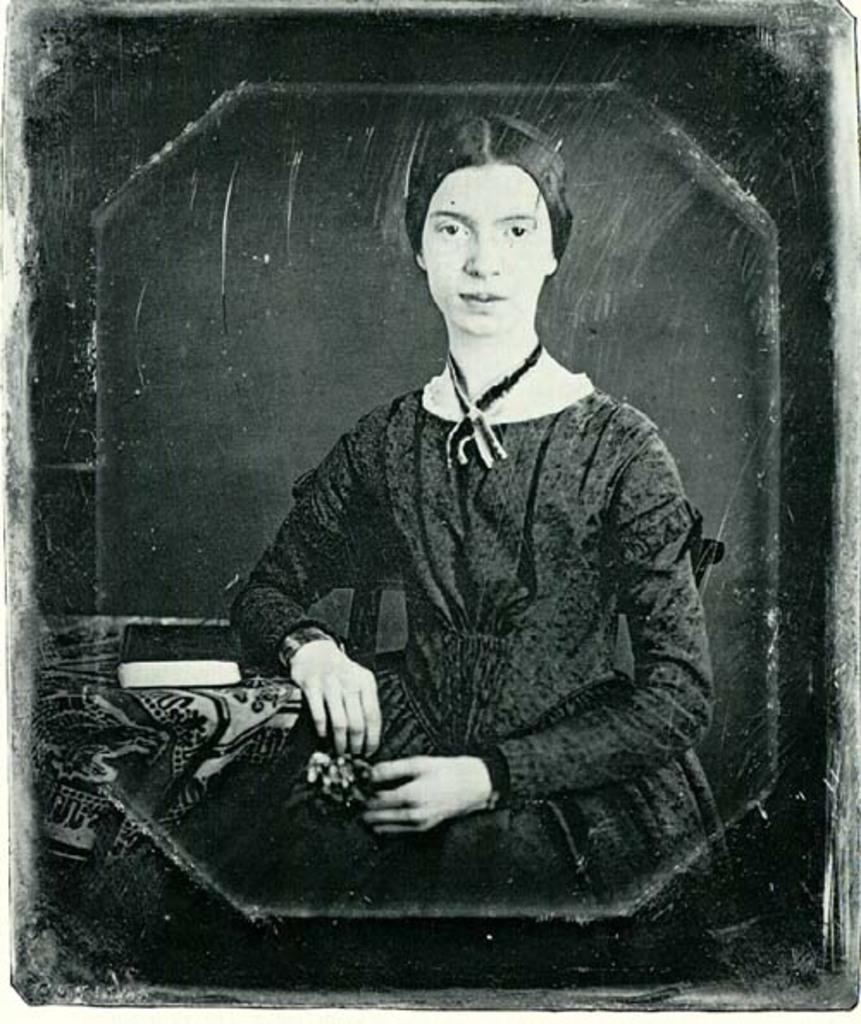What is the color scheme of the image? The image is black and white. What can be seen in the image? There is a lady sitting in the image. What is located near the lady? There is a table near the lady. What object is on the table? There is a book on the table. Can you see any farm animals in the image? There are no farm animals present in the image. What type of tree is visible in the image? There is no tree visible in the image. 